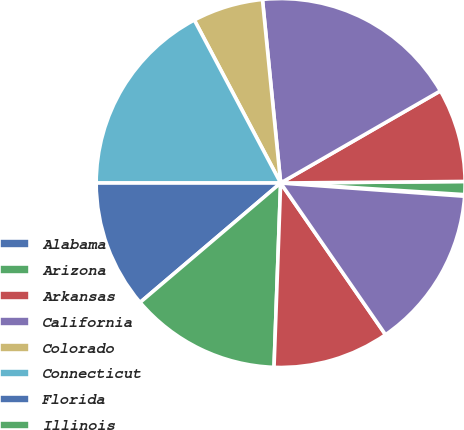Convert chart to OTSL. <chart><loc_0><loc_0><loc_500><loc_500><pie_chart><fcel>Alabama<fcel>Arizona<fcel>Arkansas<fcel>California<fcel>Colorado<fcel>Connecticut<fcel>Florida<fcel>Illinois<fcel>Kentucky<fcel>Maryland<nl><fcel>0.14%<fcel>1.14%<fcel>8.19%<fcel>18.25%<fcel>6.18%<fcel>17.25%<fcel>11.21%<fcel>13.22%<fcel>10.2%<fcel>14.23%<nl></chart> 